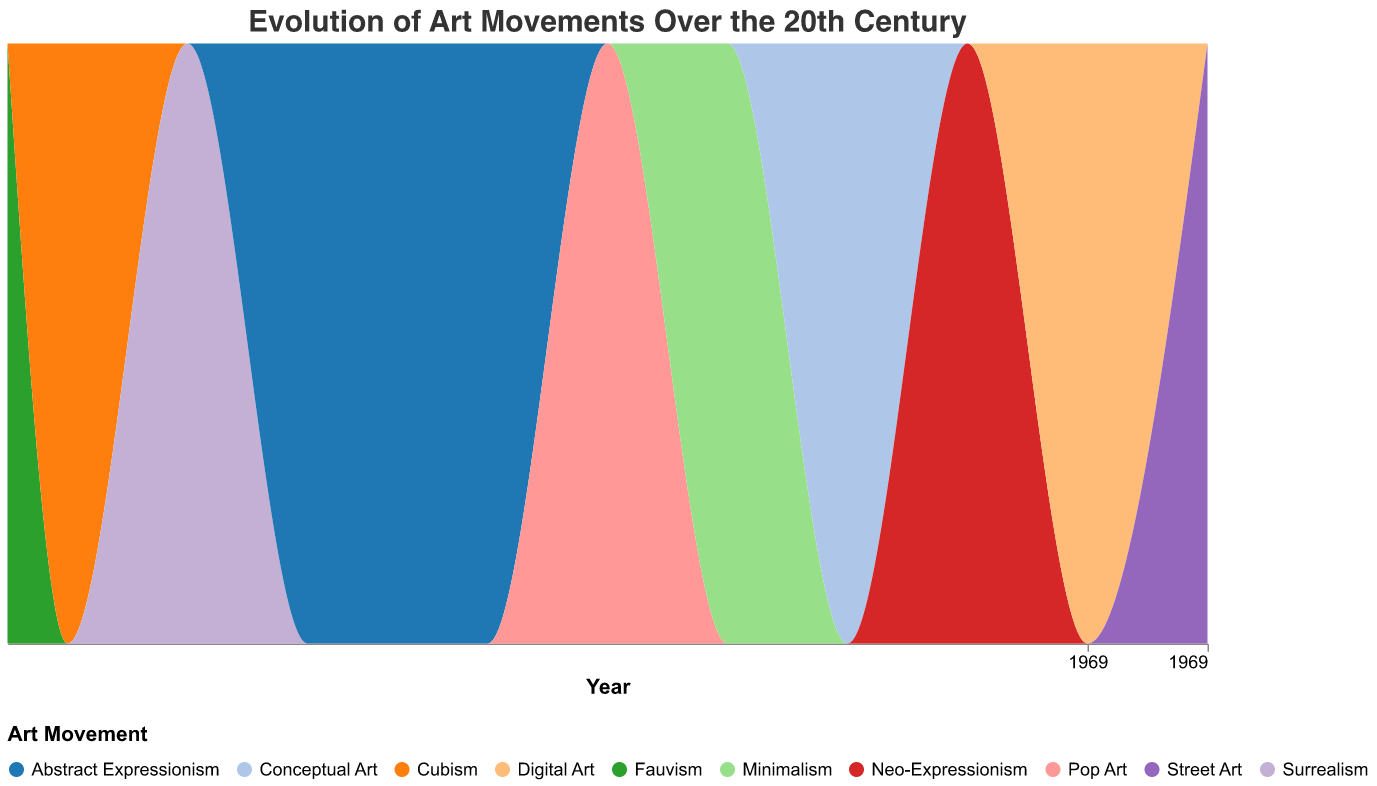How many art movements are represented in the figure? Count the number of unique art movements shown in the color legend or different color areas in the stream graph.
Answer: 11 Which art movement is associated with the Tech Boom? Find the year corresponding to the Tech Boom (1995) and check the art movement listed for that year in the tooltip or color area.
Answer: Digital Art What is the influence of the Industrial Revolution on Fauvism? Find the tooltip associated with the year 1905 for Fauvism and read the influence description.
Answer: Increased use of bright colors to reflect optimism and modernity In which decade does Surrealism appear in the figure? Identify the year associated with Surrealism from the color area or tooltip and note the decade (e.g., 1920s).
Answer: 1920s Which art movement reflects the influence of the Civil Rights Movement? Check the tooltip for the year 1965 to find the associated art movement and its influence.
Answer: Minimalism How many art movements originated before World War II (before 1939)? Identify the years and art movements from the figure and count those before 1939. There are Fauvism (1905), Cubism (1910), Surrealism (1920), and Abstract Expressionism (1930).
Answer: 4 Compare the influences of World War I and Vietnam War on art movements. Which kind of art aesthetics did these events inspire? Check the tooltips for the years of World War I (1910) and Vietnam War (1975) to compare influences. World War I inspired Cubism characterized by fragmented structures and abstract forms, while Vietnam War influenced Conceptual Art characterized by art as an idea rather than a visual product.
Answer: Cubism: fragmented structures and abstract forms; Conceptual Art: art as an idea Which art movements took place during wartime periods mentioned in the figure? Identify the art movements during World War I (1910), World War II (ending in 1945), Cold War (1985), and Vietnam War (1975) based on the years.
Answer: Cubism, Abstract Expressionism, Conceptual Art, Neo-Expressionism Which major event influenced two different art movements in the figure, and what are those art movements? Check for any major events listed more than once in the tooltips and identify the corresponding art movements around those years. The End of World War II (1945) influenced Abstract Expressionism and the Great Depression (1930) also influenced Abstract Expressionism.
Answer: Abstract Expressionism (1930, 1945) What kind of societal changes are reflected in the art movement of the early 2000s? Identify the art movement in the 2000s from the tooltip (Street Art) and explain its influence (Reflection of social issues and accessibility of art).
Answer: Reflection of social issues and accessibility of art 